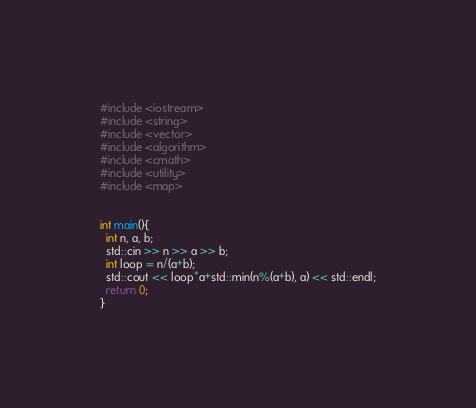<code> <loc_0><loc_0><loc_500><loc_500><_C++_>#include <iostream>
#include <string>
#include <vector>
#include <algorithm>
#include <cmath>
#include <utility>
#include <map>


int main(){
  int n, a, b;
  std::cin >> n >> a >> b;
  int loop = n/(a+b);
  std::cout << loop*a+std::min(n%(a+b), a) << std::endl;
  return 0;
}</code> 